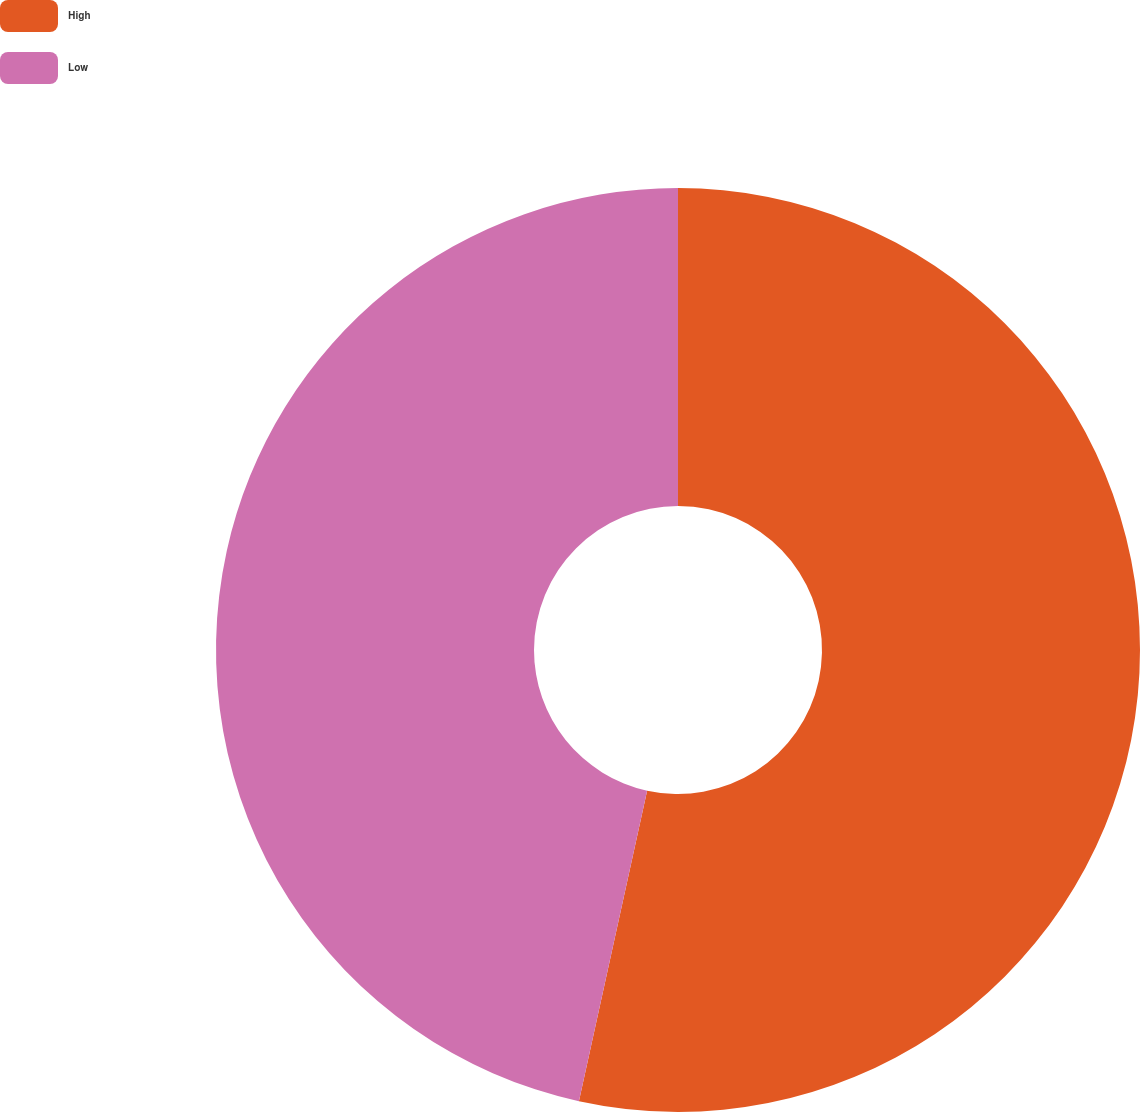Convert chart to OTSL. <chart><loc_0><loc_0><loc_500><loc_500><pie_chart><fcel>High<fcel>Low<nl><fcel>53.44%<fcel>46.56%<nl></chart> 